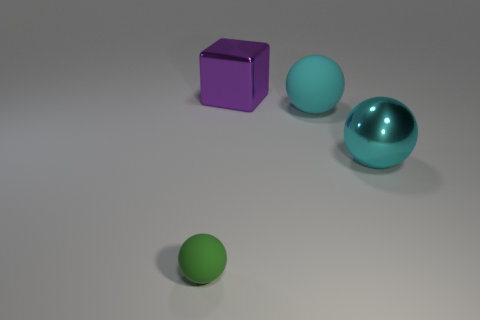What color is the matte ball that is the same size as the metallic block?
Provide a short and direct response. Cyan. What is the shape of the large object that is right of the big purple block and behind the large metallic ball?
Give a very brief answer. Sphere. There is a rubber thing that is behind the big shiny thing on the right side of the big purple cube; how big is it?
Provide a short and direct response. Large. What number of large metallic spheres have the same color as the big matte thing?
Make the answer very short. 1. How many other objects are there of the same size as the cyan shiny object?
Provide a succinct answer. 2. There is a thing that is both on the left side of the large cyan rubber sphere and in front of the big purple metal cube; what is its size?
Provide a short and direct response. Small. What number of other big objects have the same shape as the green object?
Your answer should be very brief. 2. What is the material of the tiny green object?
Your response must be concise. Rubber. Do the big purple object and the green matte object have the same shape?
Your response must be concise. No. Is there a red cylinder made of the same material as the block?
Your response must be concise. No. 